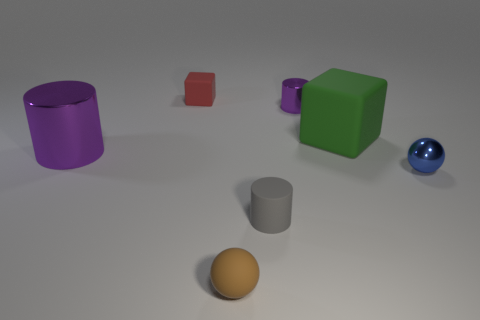Add 3 tiny brown balls. How many objects exist? 10 Subtract all balls. How many objects are left? 5 Subtract 0 green balls. How many objects are left? 7 Subtract all green objects. Subtract all purple metal things. How many objects are left? 4 Add 4 tiny brown balls. How many tiny brown balls are left? 5 Add 1 gray matte objects. How many gray matte objects exist? 2 